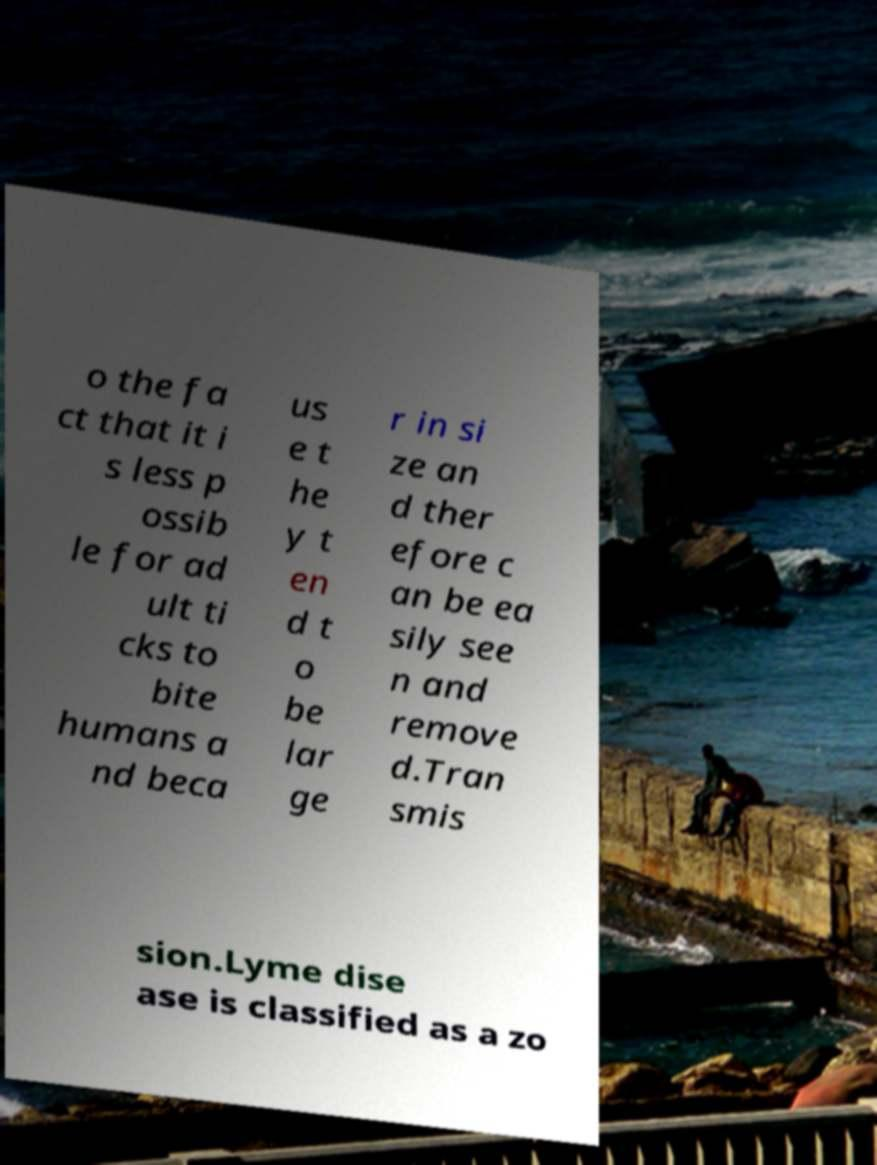What messages or text are displayed in this image? I need them in a readable, typed format. o the fa ct that it i s less p ossib le for ad ult ti cks to bite humans a nd beca us e t he y t en d t o be lar ge r in si ze an d ther efore c an be ea sily see n and remove d.Tran smis sion.Lyme dise ase is classified as a zo 